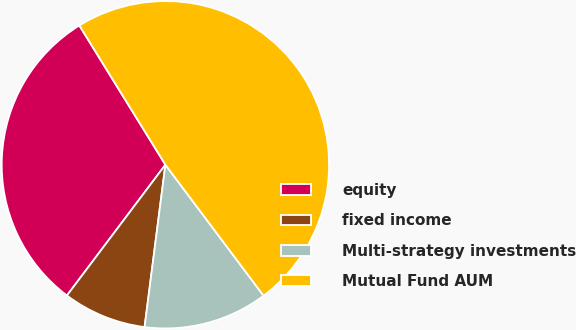Convert chart to OTSL. <chart><loc_0><loc_0><loc_500><loc_500><pie_chart><fcel>equity<fcel>fixed income<fcel>Multi-strategy investments<fcel>Mutual Fund AUM<nl><fcel>30.92%<fcel>8.24%<fcel>12.27%<fcel>48.57%<nl></chart> 